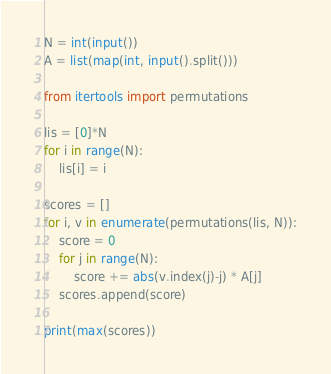Convert code to text. <code><loc_0><loc_0><loc_500><loc_500><_Python_>N = int(input())
A = list(map(int, input().split()))

from itertools import permutations

lis = [0]*N
for i in range(N):
    lis[i] = i

scores = []
for i, v in enumerate(permutations(lis, N)):
    score = 0
    for j in range(N): 
        score += abs(v.index(j)-j) * A[j]
    scores.append(score)

print(max(scores))</code> 